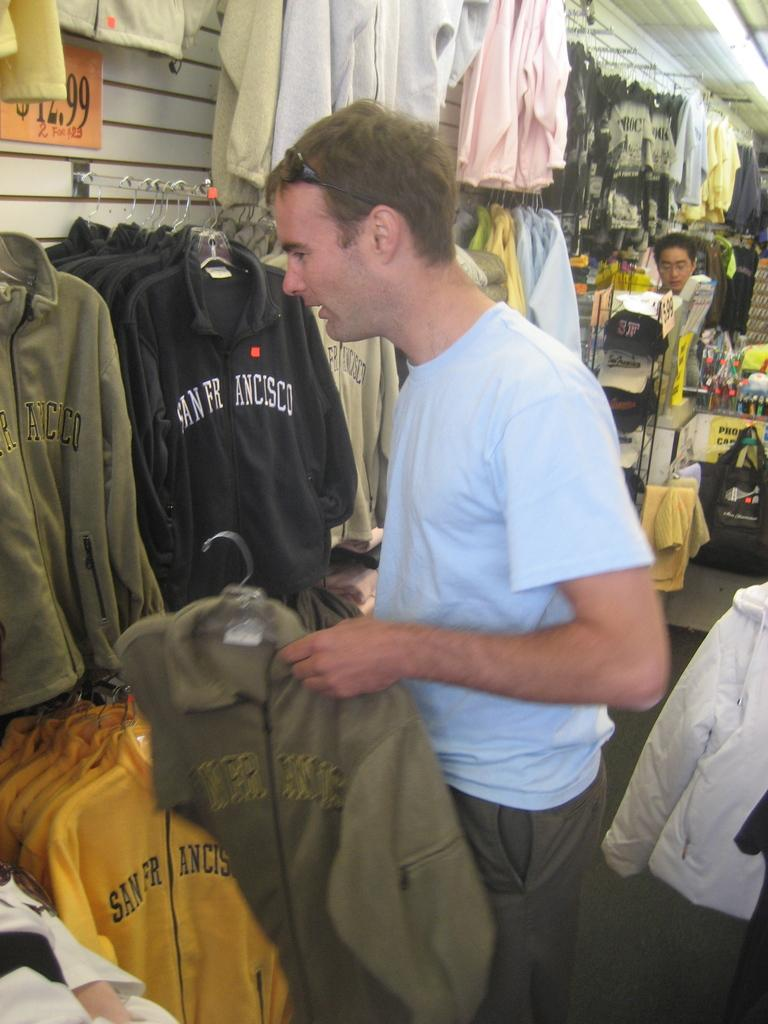<image>
Render a clear and concise summary of the photo. A man wearing a white t-shirt is in a clothes store looking at various tops with San Franscisco written on them 